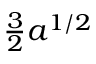Convert formula to latex. <formula><loc_0><loc_0><loc_500><loc_500>\frac { 3 } { 2 } a ^ { 1 / 2 }</formula> 